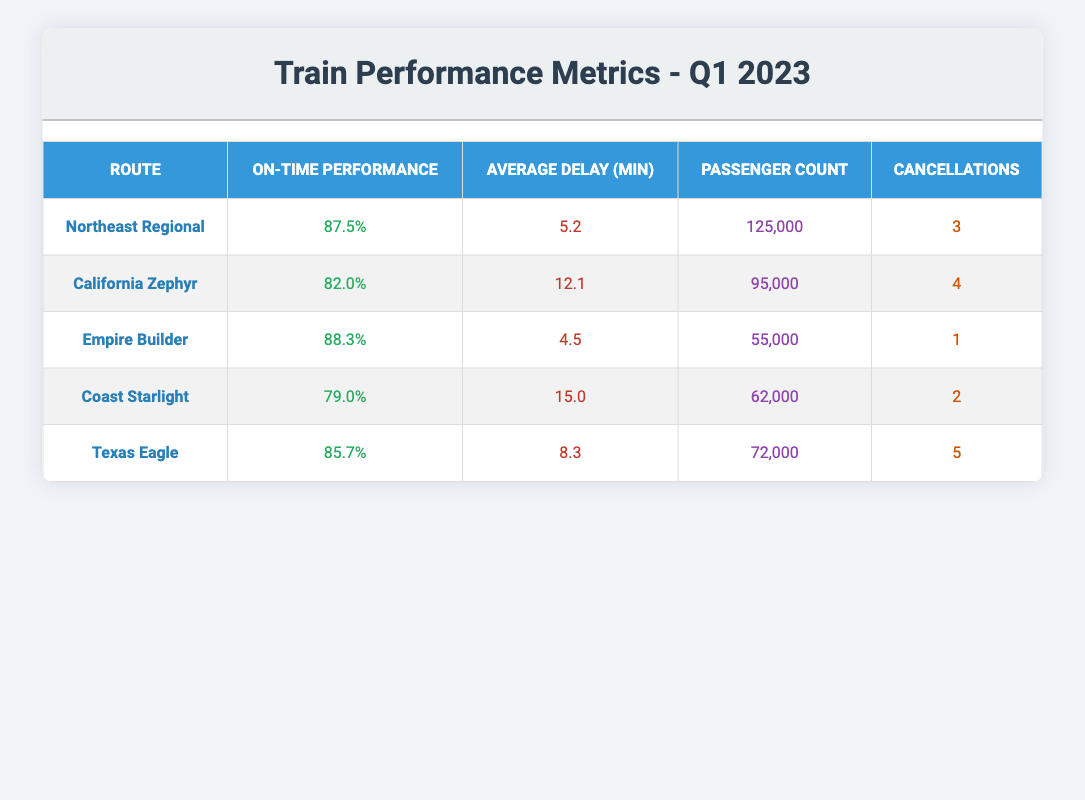What is the on-time performance percentage of the Northeast Regional route? The table lists the on-time performance for each route, and for the Northeast Regional, it is shown as 87.5%
Answer: 87.5% Which train had the highest passenger count in Q1 2023? Looking at the passenger count column, the highest number is 125,000 for the Northeast Regional route
Answer: Northeast Regional What is the average delay in minutes for the California Zephyr? The average delay for the California Zephyr is displayed in the table as 12.1 minutes
Answer: 12.1 How many total cancellations occurred across all routes in Q1 2023? By adding the cancellations for each route: 3 + 4 + 1 + 2 + 5 = 15
Answer: 15 Is the on-time performance for the Coast Starlight above 80%? The table shows the Coast Starlight's on-time performance as 79.0%, which is below 80%
Answer: No What is the difference in on-time performance between the Empire Builder and the Texas Eagle routes? Empire Builder has an on-time performance of 88.3% and Texas Eagle has 85.7%. The difference is calculated as 88.3 - 85.7 = 2.6%
Answer: 2.6% Which route had the lowest average delay in minutes? By comparing the average delays, Empire Builder has the lowest at 4.5 minutes
Answer: Empire Builder Does the California Zephyr have a higher cancellation rate compared to the Empire Builder? California Zephyr has 4 cancellations and Empire Builder has 1 cancellation. Since 4 > 1, it means the California Zephyr has a higher rate
Answer: Yes What is the average on-time performance percentage across all listed routes? The average is calculated by adding all the on-time performances: (87.5 + 82.0 + 88.3 + 79.0 + 85.7) / 5 = 84.1%
Answer: 84.1% 